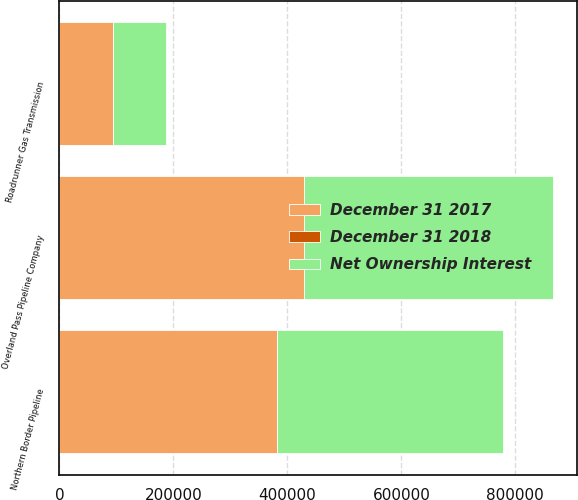Convert chart. <chart><loc_0><loc_0><loc_500><loc_500><stacked_bar_chart><ecel><fcel>Northern Border Pipeline<fcel>Overland Pass Pipeline Company<fcel>Roadrunner Gas Transmission<nl><fcel>December 31 2018<fcel>50<fcel>50<fcel>50<nl><fcel>December 31 2017<fcel>381623<fcel>429295<fcel>93857<nl><fcel>Net Ownership Interest<fcel>396800<fcel>436111<fcel>93048<nl></chart> 